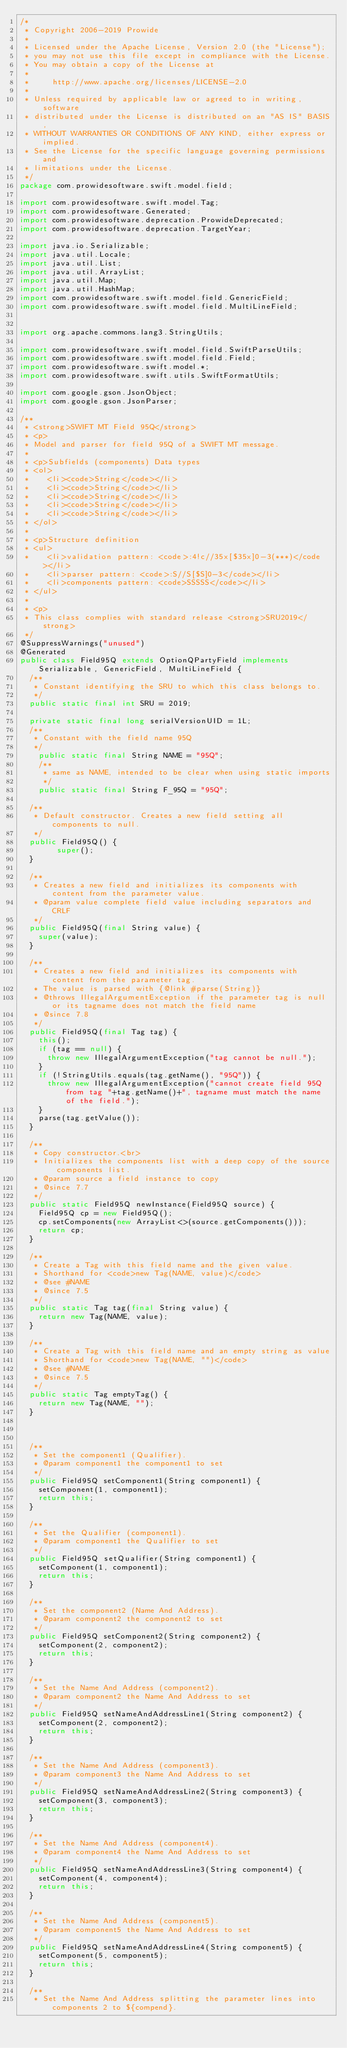Convert code to text. <code><loc_0><loc_0><loc_500><loc_500><_Java_>/*
 * Copyright 2006-2019 Prowide
 *
 * Licensed under the Apache License, Version 2.0 (the "License");
 * you may not use this file except in compliance with the License.
 * You may obtain a copy of the License at
 *
 *     http://www.apache.org/licenses/LICENSE-2.0
 *
 * Unless required by applicable law or agreed to in writing, software
 * distributed under the License is distributed on an "AS IS" BASIS,
 * WITHOUT WARRANTIES OR CONDITIONS OF ANY KIND, either express or implied.
 * See the License for the specific language governing permissions and
 * limitations under the License.
 */
package com.prowidesoftware.swift.model.field;

import com.prowidesoftware.swift.model.Tag;
import com.prowidesoftware.Generated;
import com.prowidesoftware.deprecation.ProwideDeprecated;
import com.prowidesoftware.deprecation.TargetYear;

import java.io.Serializable;
import java.util.Locale;
import java.util.List;
import java.util.ArrayList;
import java.util.Map;
import java.util.HashMap;
import com.prowidesoftware.swift.model.field.GenericField;
import com.prowidesoftware.swift.model.field.MultiLineField;


import org.apache.commons.lang3.StringUtils;

import com.prowidesoftware.swift.model.field.SwiftParseUtils;
import com.prowidesoftware.swift.model.field.Field;
import com.prowidesoftware.swift.model.*;
import com.prowidesoftware.swift.utils.SwiftFormatUtils;

import com.google.gson.JsonObject;
import com.google.gson.JsonParser;

/**
 * <strong>SWIFT MT Field 95Q</strong>
 * <p>
 * Model and parser for field 95Q of a SWIFT MT message.
 *
 * <p>Subfields (components) Data types
 * <ol>
 * 		<li><code>String</code></li>
 * 		<li><code>String</code></li>
 * 		<li><code>String</code></li>
 * 		<li><code>String</code></li>
 * 		<li><code>String</code></li>
 * </ol>
 *
 * <p>Structure definition
 * <ul>
 * 		<li>validation pattern: <code>:4!c//35x[$35x]0-3(***)</code></li>
 * 		<li>parser pattern: <code>:S//S[$S]0-3</code></li>
 * 		<li>components pattern: <code>SSSSS</code></li>
 * </ul>
 *
 * <p>
 * This class complies with standard release <strong>SRU2019</strong>
 */
@SuppressWarnings("unused")
@Generated
public class Field95Q extends OptionQPartyField implements Serializable, GenericField, MultiLineField {
	/**
	 * Constant identifying the SRU to which this class belongs to.
	 */
	public static final int SRU = 2019;

	private static final long serialVersionUID = 1L;
	/**
	 * Constant with the field name 95Q
	 */
    public static final String NAME = "95Q";
    /**
     * same as NAME, intended to be clear when using static imports
     */
    public static final String F_95Q = "95Q";

	/**
	 * Default constructor. Creates a new field setting all components to null.
	 */
	public Field95Q() {
        super();
	}
	    					
	/**
	 * Creates a new field and initializes its components with content from the parameter value.
	 * @param value complete field value including separators and CRLF
	 */
	public Field95Q(final String value) {
		super(value);
	}
	
	/**
	 * Creates a new field and initializes its components with content from the parameter tag.
	 * The value is parsed with {@link #parse(String)} 	 
	 * @throws IllegalArgumentException if the parameter tag is null or its tagname does not match the field name
	 * @since 7.8
	 */
	public Field95Q(final Tag tag) {
		this();
		if (tag == null) {
			throw new IllegalArgumentException("tag cannot be null.");
		}
		if (!StringUtils.equals(tag.getName(), "95Q")) {
			throw new IllegalArgumentException("cannot create field 95Q from tag "+tag.getName()+", tagname must match the name of the field.");
		}
		parse(tag.getValue());
	}

	/**
	 * Copy constructor.<br>
	 * Initializes the components list with a deep copy of the source components list.
	 * @param source a field instance to copy
	 * @since 7.7
	 */
	public static Field95Q newInstance(Field95Q source) {
		Field95Q cp = new Field95Q();
		cp.setComponents(new ArrayList<>(source.getComponents()));
		return cp;
	}

	/**
	 * Create a Tag with this field name and the given value.
	 * Shorthand for <code>new Tag(NAME, value)</code>
	 * @see #NAME
	 * @since 7.5
	 */
	public static Tag tag(final String value) {
		return new Tag(NAME, value);
	}

	/**
	 * Create a Tag with this field name and an empty string as value
	 * Shorthand for <code>new Tag(NAME, "")</code>
	 * @see #NAME
	 * @since 7.5
	 */
	public static Tag emptyTag() {
		return new Tag(NAME, "");
	}



	/**
	 * Set the component1 (Qualifier).
	 * @param component1 the component1 to set
	 */
	public Field95Q setComponent1(String component1) {
		setComponent(1, component1);
		return this;
	}
	
	/**
	 * Set the Qualifier (component1).
	 * @param component1 the Qualifier to set
	 */
	public Field95Q setQualifier(String component1) {
		setComponent(1, component1);
		return this;
	}

	/**
	 * Set the component2 (Name And Address).
	 * @param component2 the component2 to set
	 */
	public Field95Q setComponent2(String component2) {
		setComponent(2, component2);
		return this;
	}

	/**
	 * Set the Name And Address (component2).
	 * @param component2 the Name And Address to set
	 */
	public Field95Q setNameAndAddressLine1(String component2) {
		setComponent(2, component2);
		return this;
	}

	/**
	 * Set the Name And Address (component3).
	 * @param component3 the Name And Address to set
	 */
	public Field95Q setNameAndAddressLine2(String component3) {
		setComponent(3, component3);
		return this;
	}

	/**
	 * Set the Name And Address (component4).
	 * @param component4 the Name And Address to set
	 */
	public Field95Q setNameAndAddressLine3(String component4) {
		setComponent(4, component4);
		return this;
	}

	/**
	 * Set the Name And Address (component5).
	 * @param component5 the Name And Address to set
	 */
	public Field95Q setNameAndAddressLine4(String component5) {
		setComponent(5, component5);
		return this;
	}

	/**
	 * Set the Name And Address splitting the parameter lines into components 2 to ${compend}.</code> 